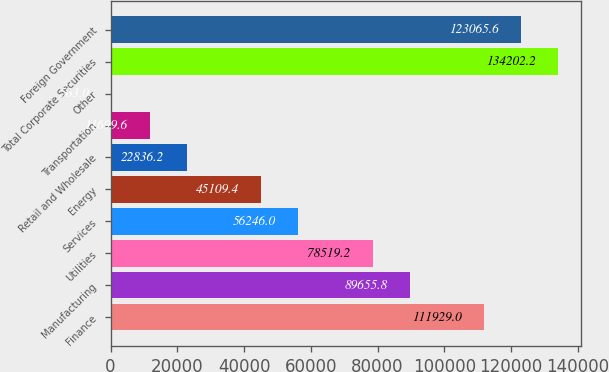Convert chart. <chart><loc_0><loc_0><loc_500><loc_500><bar_chart><fcel>Finance<fcel>Manufacturing<fcel>Utilities<fcel>Services<fcel>Energy<fcel>Retail and Wholesale<fcel>Transportation<fcel>Other<fcel>Total Corporate Securities<fcel>Foreign Government<nl><fcel>111929<fcel>89655.8<fcel>78519.2<fcel>56246<fcel>45109.4<fcel>22836.2<fcel>11699.6<fcel>563<fcel>134202<fcel>123066<nl></chart> 